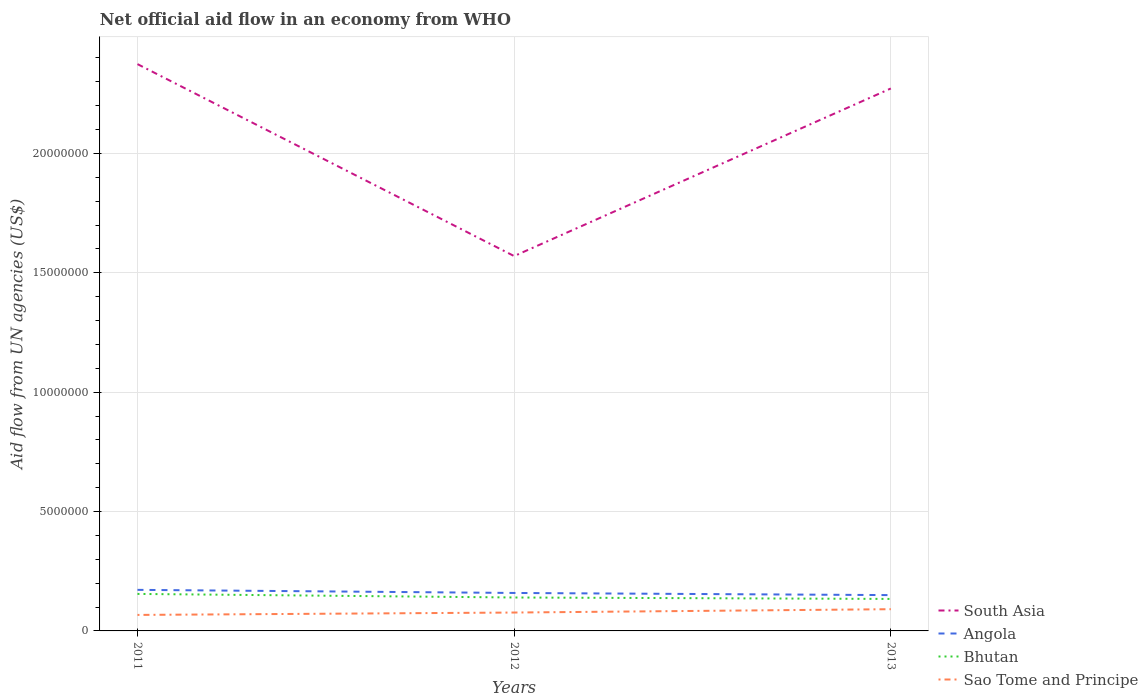Does the line corresponding to Sao Tome and Principe intersect with the line corresponding to Angola?
Offer a very short reply. No. Is the number of lines equal to the number of legend labels?
Your answer should be compact. Yes. Across all years, what is the maximum net official aid flow in Sao Tome and Principe?
Provide a succinct answer. 6.70e+05. What is the total net official aid flow in South Asia in the graph?
Your response must be concise. -7.02e+06. What is the difference between the highest and the second highest net official aid flow in South Asia?
Your response must be concise. 8.04e+06. What is the difference between the highest and the lowest net official aid flow in South Asia?
Your answer should be compact. 2. Is the net official aid flow in Angola strictly greater than the net official aid flow in Bhutan over the years?
Keep it short and to the point. No. How many lines are there?
Make the answer very short. 4. How many years are there in the graph?
Your response must be concise. 3. Are the values on the major ticks of Y-axis written in scientific E-notation?
Your response must be concise. No. Does the graph contain any zero values?
Your answer should be very brief. No. Does the graph contain grids?
Offer a very short reply. Yes. Where does the legend appear in the graph?
Offer a terse response. Bottom right. How are the legend labels stacked?
Offer a very short reply. Vertical. What is the title of the graph?
Provide a succinct answer. Net official aid flow in an economy from WHO. Does "Gambia, The" appear as one of the legend labels in the graph?
Your answer should be very brief. No. What is the label or title of the Y-axis?
Offer a very short reply. Aid flow from UN agencies (US$). What is the Aid flow from UN agencies (US$) in South Asia in 2011?
Your response must be concise. 2.37e+07. What is the Aid flow from UN agencies (US$) in Angola in 2011?
Provide a succinct answer. 1.72e+06. What is the Aid flow from UN agencies (US$) in Bhutan in 2011?
Make the answer very short. 1.55e+06. What is the Aid flow from UN agencies (US$) of Sao Tome and Principe in 2011?
Ensure brevity in your answer.  6.70e+05. What is the Aid flow from UN agencies (US$) of South Asia in 2012?
Offer a very short reply. 1.57e+07. What is the Aid flow from UN agencies (US$) in Angola in 2012?
Keep it short and to the point. 1.59e+06. What is the Aid flow from UN agencies (US$) in Bhutan in 2012?
Make the answer very short. 1.40e+06. What is the Aid flow from UN agencies (US$) of Sao Tome and Principe in 2012?
Your answer should be compact. 7.70e+05. What is the Aid flow from UN agencies (US$) of South Asia in 2013?
Your response must be concise. 2.27e+07. What is the Aid flow from UN agencies (US$) of Angola in 2013?
Your response must be concise. 1.50e+06. What is the Aid flow from UN agencies (US$) of Bhutan in 2013?
Give a very brief answer. 1.34e+06. What is the Aid flow from UN agencies (US$) in Sao Tome and Principe in 2013?
Make the answer very short. 9.10e+05. Across all years, what is the maximum Aid flow from UN agencies (US$) of South Asia?
Your answer should be compact. 2.37e+07. Across all years, what is the maximum Aid flow from UN agencies (US$) in Angola?
Keep it short and to the point. 1.72e+06. Across all years, what is the maximum Aid flow from UN agencies (US$) in Bhutan?
Give a very brief answer. 1.55e+06. Across all years, what is the maximum Aid flow from UN agencies (US$) in Sao Tome and Principe?
Provide a succinct answer. 9.10e+05. Across all years, what is the minimum Aid flow from UN agencies (US$) of South Asia?
Make the answer very short. 1.57e+07. Across all years, what is the minimum Aid flow from UN agencies (US$) of Angola?
Make the answer very short. 1.50e+06. Across all years, what is the minimum Aid flow from UN agencies (US$) in Bhutan?
Your answer should be very brief. 1.34e+06. Across all years, what is the minimum Aid flow from UN agencies (US$) of Sao Tome and Principe?
Provide a succinct answer. 6.70e+05. What is the total Aid flow from UN agencies (US$) in South Asia in the graph?
Your response must be concise. 6.22e+07. What is the total Aid flow from UN agencies (US$) in Angola in the graph?
Give a very brief answer. 4.81e+06. What is the total Aid flow from UN agencies (US$) of Bhutan in the graph?
Your answer should be very brief. 4.29e+06. What is the total Aid flow from UN agencies (US$) in Sao Tome and Principe in the graph?
Make the answer very short. 2.35e+06. What is the difference between the Aid flow from UN agencies (US$) in South Asia in 2011 and that in 2012?
Keep it short and to the point. 8.04e+06. What is the difference between the Aid flow from UN agencies (US$) in Sao Tome and Principe in 2011 and that in 2012?
Your answer should be compact. -1.00e+05. What is the difference between the Aid flow from UN agencies (US$) of South Asia in 2011 and that in 2013?
Offer a very short reply. 1.02e+06. What is the difference between the Aid flow from UN agencies (US$) in Angola in 2011 and that in 2013?
Provide a succinct answer. 2.20e+05. What is the difference between the Aid flow from UN agencies (US$) of Bhutan in 2011 and that in 2013?
Your answer should be very brief. 2.10e+05. What is the difference between the Aid flow from UN agencies (US$) in South Asia in 2012 and that in 2013?
Your answer should be compact. -7.02e+06. What is the difference between the Aid flow from UN agencies (US$) of Angola in 2012 and that in 2013?
Ensure brevity in your answer.  9.00e+04. What is the difference between the Aid flow from UN agencies (US$) in Bhutan in 2012 and that in 2013?
Your answer should be very brief. 6.00e+04. What is the difference between the Aid flow from UN agencies (US$) in South Asia in 2011 and the Aid flow from UN agencies (US$) in Angola in 2012?
Keep it short and to the point. 2.22e+07. What is the difference between the Aid flow from UN agencies (US$) in South Asia in 2011 and the Aid flow from UN agencies (US$) in Bhutan in 2012?
Offer a very short reply. 2.23e+07. What is the difference between the Aid flow from UN agencies (US$) of South Asia in 2011 and the Aid flow from UN agencies (US$) of Sao Tome and Principe in 2012?
Provide a short and direct response. 2.30e+07. What is the difference between the Aid flow from UN agencies (US$) in Angola in 2011 and the Aid flow from UN agencies (US$) in Bhutan in 2012?
Provide a succinct answer. 3.20e+05. What is the difference between the Aid flow from UN agencies (US$) of Angola in 2011 and the Aid flow from UN agencies (US$) of Sao Tome and Principe in 2012?
Offer a terse response. 9.50e+05. What is the difference between the Aid flow from UN agencies (US$) of Bhutan in 2011 and the Aid flow from UN agencies (US$) of Sao Tome and Principe in 2012?
Keep it short and to the point. 7.80e+05. What is the difference between the Aid flow from UN agencies (US$) of South Asia in 2011 and the Aid flow from UN agencies (US$) of Angola in 2013?
Give a very brief answer. 2.22e+07. What is the difference between the Aid flow from UN agencies (US$) of South Asia in 2011 and the Aid flow from UN agencies (US$) of Bhutan in 2013?
Make the answer very short. 2.24e+07. What is the difference between the Aid flow from UN agencies (US$) in South Asia in 2011 and the Aid flow from UN agencies (US$) in Sao Tome and Principe in 2013?
Provide a short and direct response. 2.28e+07. What is the difference between the Aid flow from UN agencies (US$) in Angola in 2011 and the Aid flow from UN agencies (US$) in Bhutan in 2013?
Your answer should be very brief. 3.80e+05. What is the difference between the Aid flow from UN agencies (US$) of Angola in 2011 and the Aid flow from UN agencies (US$) of Sao Tome and Principe in 2013?
Make the answer very short. 8.10e+05. What is the difference between the Aid flow from UN agencies (US$) in Bhutan in 2011 and the Aid flow from UN agencies (US$) in Sao Tome and Principe in 2013?
Your response must be concise. 6.40e+05. What is the difference between the Aid flow from UN agencies (US$) of South Asia in 2012 and the Aid flow from UN agencies (US$) of Angola in 2013?
Your response must be concise. 1.42e+07. What is the difference between the Aid flow from UN agencies (US$) of South Asia in 2012 and the Aid flow from UN agencies (US$) of Bhutan in 2013?
Keep it short and to the point. 1.44e+07. What is the difference between the Aid flow from UN agencies (US$) in South Asia in 2012 and the Aid flow from UN agencies (US$) in Sao Tome and Principe in 2013?
Provide a short and direct response. 1.48e+07. What is the difference between the Aid flow from UN agencies (US$) in Angola in 2012 and the Aid flow from UN agencies (US$) in Bhutan in 2013?
Keep it short and to the point. 2.50e+05. What is the difference between the Aid flow from UN agencies (US$) in Angola in 2012 and the Aid flow from UN agencies (US$) in Sao Tome and Principe in 2013?
Offer a very short reply. 6.80e+05. What is the average Aid flow from UN agencies (US$) of South Asia per year?
Provide a succinct answer. 2.07e+07. What is the average Aid flow from UN agencies (US$) of Angola per year?
Provide a short and direct response. 1.60e+06. What is the average Aid flow from UN agencies (US$) of Bhutan per year?
Provide a succinct answer. 1.43e+06. What is the average Aid flow from UN agencies (US$) in Sao Tome and Principe per year?
Give a very brief answer. 7.83e+05. In the year 2011, what is the difference between the Aid flow from UN agencies (US$) in South Asia and Aid flow from UN agencies (US$) in Angola?
Make the answer very short. 2.20e+07. In the year 2011, what is the difference between the Aid flow from UN agencies (US$) of South Asia and Aid flow from UN agencies (US$) of Bhutan?
Your answer should be very brief. 2.22e+07. In the year 2011, what is the difference between the Aid flow from UN agencies (US$) in South Asia and Aid flow from UN agencies (US$) in Sao Tome and Principe?
Provide a short and direct response. 2.31e+07. In the year 2011, what is the difference between the Aid flow from UN agencies (US$) of Angola and Aid flow from UN agencies (US$) of Sao Tome and Principe?
Offer a terse response. 1.05e+06. In the year 2011, what is the difference between the Aid flow from UN agencies (US$) in Bhutan and Aid flow from UN agencies (US$) in Sao Tome and Principe?
Provide a short and direct response. 8.80e+05. In the year 2012, what is the difference between the Aid flow from UN agencies (US$) in South Asia and Aid flow from UN agencies (US$) in Angola?
Your answer should be compact. 1.41e+07. In the year 2012, what is the difference between the Aid flow from UN agencies (US$) of South Asia and Aid flow from UN agencies (US$) of Bhutan?
Your answer should be compact. 1.43e+07. In the year 2012, what is the difference between the Aid flow from UN agencies (US$) in South Asia and Aid flow from UN agencies (US$) in Sao Tome and Principe?
Your answer should be very brief. 1.49e+07. In the year 2012, what is the difference between the Aid flow from UN agencies (US$) of Angola and Aid flow from UN agencies (US$) of Bhutan?
Keep it short and to the point. 1.90e+05. In the year 2012, what is the difference between the Aid flow from UN agencies (US$) in Angola and Aid flow from UN agencies (US$) in Sao Tome and Principe?
Offer a very short reply. 8.20e+05. In the year 2012, what is the difference between the Aid flow from UN agencies (US$) of Bhutan and Aid flow from UN agencies (US$) of Sao Tome and Principe?
Make the answer very short. 6.30e+05. In the year 2013, what is the difference between the Aid flow from UN agencies (US$) in South Asia and Aid flow from UN agencies (US$) in Angola?
Offer a very short reply. 2.12e+07. In the year 2013, what is the difference between the Aid flow from UN agencies (US$) in South Asia and Aid flow from UN agencies (US$) in Bhutan?
Ensure brevity in your answer.  2.14e+07. In the year 2013, what is the difference between the Aid flow from UN agencies (US$) in South Asia and Aid flow from UN agencies (US$) in Sao Tome and Principe?
Provide a short and direct response. 2.18e+07. In the year 2013, what is the difference between the Aid flow from UN agencies (US$) in Angola and Aid flow from UN agencies (US$) in Bhutan?
Provide a short and direct response. 1.60e+05. In the year 2013, what is the difference between the Aid flow from UN agencies (US$) in Angola and Aid flow from UN agencies (US$) in Sao Tome and Principe?
Your answer should be compact. 5.90e+05. In the year 2013, what is the difference between the Aid flow from UN agencies (US$) in Bhutan and Aid flow from UN agencies (US$) in Sao Tome and Principe?
Provide a succinct answer. 4.30e+05. What is the ratio of the Aid flow from UN agencies (US$) of South Asia in 2011 to that in 2012?
Provide a succinct answer. 1.51. What is the ratio of the Aid flow from UN agencies (US$) of Angola in 2011 to that in 2012?
Keep it short and to the point. 1.08. What is the ratio of the Aid flow from UN agencies (US$) in Bhutan in 2011 to that in 2012?
Give a very brief answer. 1.11. What is the ratio of the Aid flow from UN agencies (US$) of Sao Tome and Principe in 2011 to that in 2012?
Give a very brief answer. 0.87. What is the ratio of the Aid flow from UN agencies (US$) in South Asia in 2011 to that in 2013?
Provide a short and direct response. 1.04. What is the ratio of the Aid flow from UN agencies (US$) in Angola in 2011 to that in 2013?
Ensure brevity in your answer.  1.15. What is the ratio of the Aid flow from UN agencies (US$) in Bhutan in 2011 to that in 2013?
Keep it short and to the point. 1.16. What is the ratio of the Aid flow from UN agencies (US$) of Sao Tome and Principe in 2011 to that in 2013?
Offer a terse response. 0.74. What is the ratio of the Aid flow from UN agencies (US$) of South Asia in 2012 to that in 2013?
Ensure brevity in your answer.  0.69. What is the ratio of the Aid flow from UN agencies (US$) in Angola in 2012 to that in 2013?
Give a very brief answer. 1.06. What is the ratio of the Aid flow from UN agencies (US$) in Bhutan in 2012 to that in 2013?
Provide a succinct answer. 1.04. What is the ratio of the Aid flow from UN agencies (US$) in Sao Tome and Principe in 2012 to that in 2013?
Offer a terse response. 0.85. What is the difference between the highest and the second highest Aid flow from UN agencies (US$) of South Asia?
Your response must be concise. 1.02e+06. What is the difference between the highest and the second highest Aid flow from UN agencies (US$) of Bhutan?
Your answer should be compact. 1.50e+05. What is the difference between the highest and the second highest Aid flow from UN agencies (US$) of Sao Tome and Principe?
Make the answer very short. 1.40e+05. What is the difference between the highest and the lowest Aid flow from UN agencies (US$) of South Asia?
Ensure brevity in your answer.  8.04e+06. What is the difference between the highest and the lowest Aid flow from UN agencies (US$) in Angola?
Keep it short and to the point. 2.20e+05. 